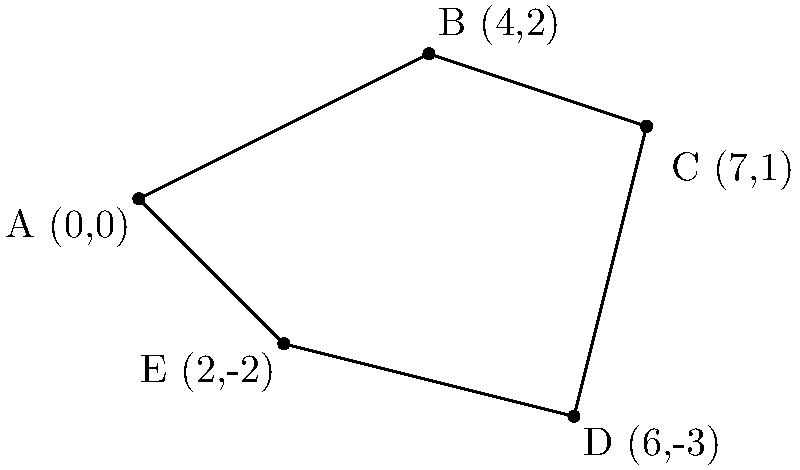The historic Whittier Town Square has an irregular pentagonal shape. The coordinates of its vertices are A(0,0), B(4,2), C(7,1), D(6,-3), and E(2,-2). Calculate the perimeter of the square to the nearest tenth of a unit. To find the perimeter, we need to calculate the distance between each pair of consecutive vertices and sum them up. We'll use the distance formula: $d = \sqrt{(x_2-x_1)^2 + (y_2-y_1)^2}$

1. Distance AB:
   $d_{AB} = \sqrt{(4-0)^2 + (2-0)^2} = \sqrt{16 + 4} = \sqrt{20} \approx 4.47$

2. Distance BC:
   $d_{BC} = \sqrt{(7-4)^2 + (1-2)^2} = \sqrt{9 + 1} = \sqrt{10} \approx 3.16$

3. Distance CD:
   $d_{CD} = \sqrt{(6-7)^2 + (-3-1)^2} = \sqrt{1 + 16} = \sqrt{17} \approx 4.12$

4. Distance DE:
   $d_{DE} = \sqrt{(2-6)^2 + (-2-(-3))^2} = \sqrt{16 + 1} = \sqrt{17} \approx 4.12$

5. Distance EA:
   $d_{EA} = \sqrt{(0-2)^2 + (0-(-2))^2} = \sqrt{4 + 4} = \sqrt{8} \approx 2.83$

Sum up all distances:
$\text{Perimeter} = 4.47 + 3.16 + 4.12 + 4.12 + 2.83 = 18.70$

Rounding to the nearest tenth: 18.7 units
Answer: 18.7 units 